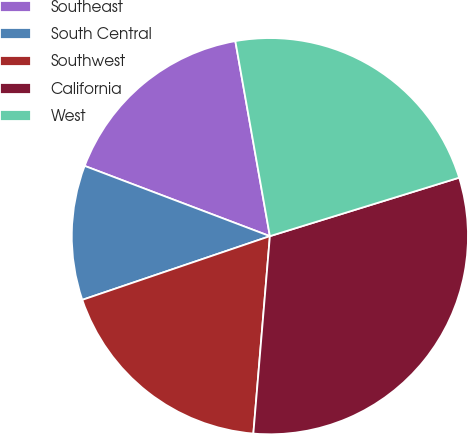<chart> <loc_0><loc_0><loc_500><loc_500><pie_chart><fcel>Southeast<fcel>South Central<fcel>Southwest<fcel>California<fcel>West<nl><fcel>16.44%<fcel>10.98%<fcel>18.46%<fcel>31.1%<fcel>23.02%<nl></chart> 